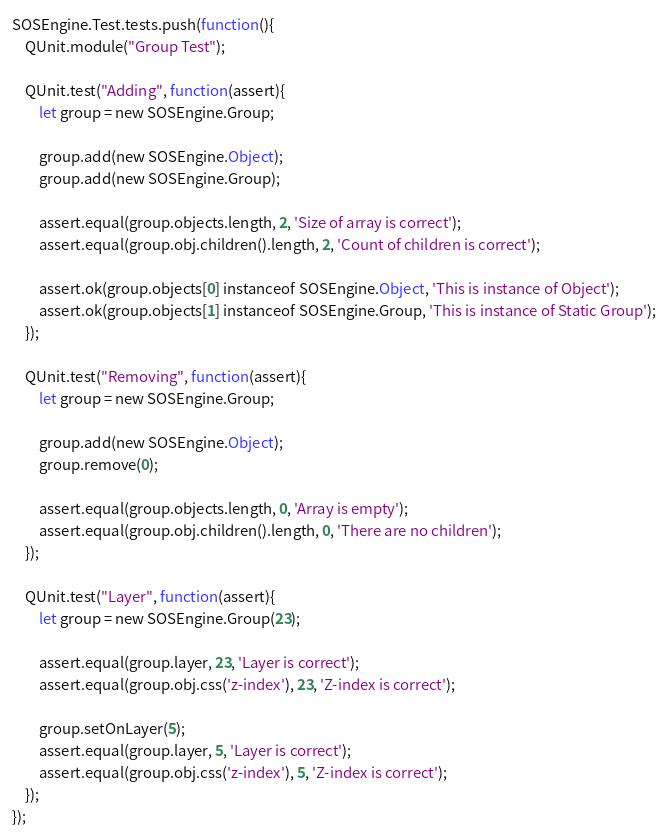Convert code to text. <code><loc_0><loc_0><loc_500><loc_500><_JavaScript_>SOSEngine.Test.tests.push(function(){
	QUnit.module("Group Test");
	
	QUnit.test("Adding", function(assert){
		let group = new SOSEngine.Group;
		
		group.add(new SOSEngine.Object);
		group.add(new SOSEngine.Group);
		
		assert.equal(group.objects.length, 2, 'Size of array is correct');
		assert.equal(group.obj.children().length, 2, 'Count of children is correct');
		
		assert.ok(group.objects[0] instanceof SOSEngine.Object, 'This is instance of Object');
		assert.ok(group.objects[1] instanceof SOSEngine.Group, 'This is instance of Static Group');
	});
	
	QUnit.test("Removing", function(assert){
		let group = new SOSEngine.Group;
		
		group.add(new SOSEngine.Object);
		group.remove(0);
		
		assert.equal(group.objects.length, 0, 'Array is empty');
		assert.equal(group.obj.children().length, 0, 'There are no children');
	});
	
	QUnit.test("Layer", function(assert){
		let group = new SOSEngine.Group(23);
		
		assert.equal(group.layer, 23, 'Layer is correct');
		assert.equal(group.obj.css('z-index'), 23, 'Z-index is correct');
		
		group.setOnLayer(5);
		assert.equal(group.layer, 5, 'Layer is correct');
		assert.equal(group.obj.css('z-index'), 5, 'Z-index is correct');
	});
});</code> 